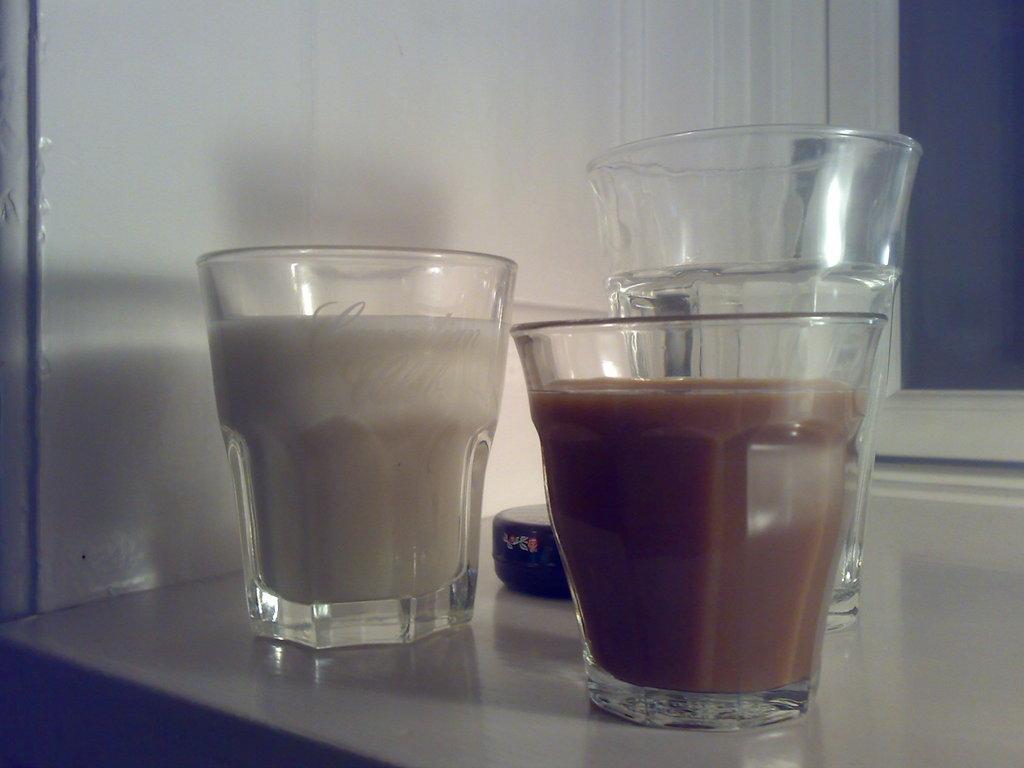In one or two sentences, can you explain what this image depicts? In this image I can see glass with drink. To the side I can see the black color object. These are on the surface. In the background I can see the wall. 